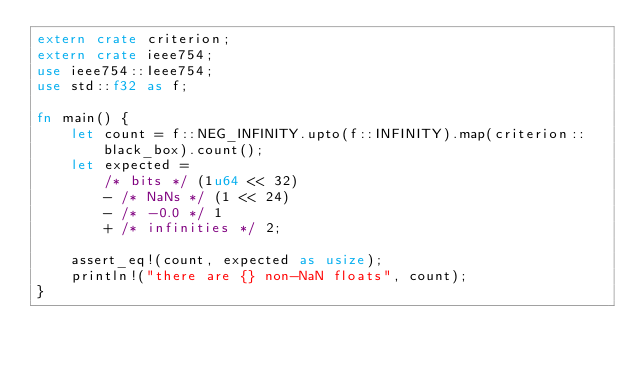Convert code to text. <code><loc_0><loc_0><loc_500><loc_500><_Rust_>extern crate criterion;
extern crate ieee754;
use ieee754::Ieee754;
use std::f32 as f;

fn main() {
    let count = f::NEG_INFINITY.upto(f::INFINITY).map(criterion::black_box).count();
    let expected =
        /* bits */ (1u64 << 32)
        - /* NaNs */ (1 << 24)
        - /* -0.0 */ 1
        + /* infinities */ 2;

    assert_eq!(count, expected as usize);
    println!("there are {} non-NaN floats", count);
}
</code> 